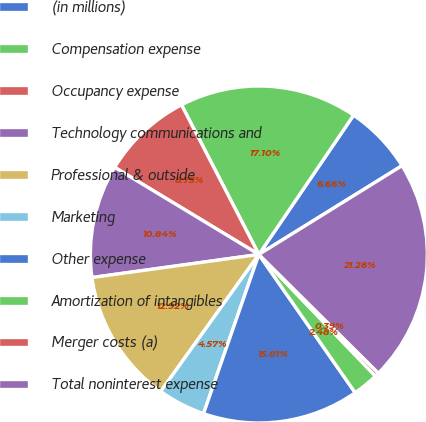Convert chart. <chart><loc_0><loc_0><loc_500><loc_500><pie_chart><fcel>(in millions)<fcel>Compensation expense<fcel>Occupancy expense<fcel>Technology communications and<fcel>Professional & outside<fcel>Marketing<fcel>Other expense<fcel>Amortization of intangibles<fcel>Merger costs (a)<fcel>Total noninterest expense<nl><fcel>6.66%<fcel>17.1%<fcel>8.75%<fcel>10.84%<fcel>12.92%<fcel>4.57%<fcel>15.01%<fcel>2.48%<fcel>0.39%<fcel>21.28%<nl></chart> 